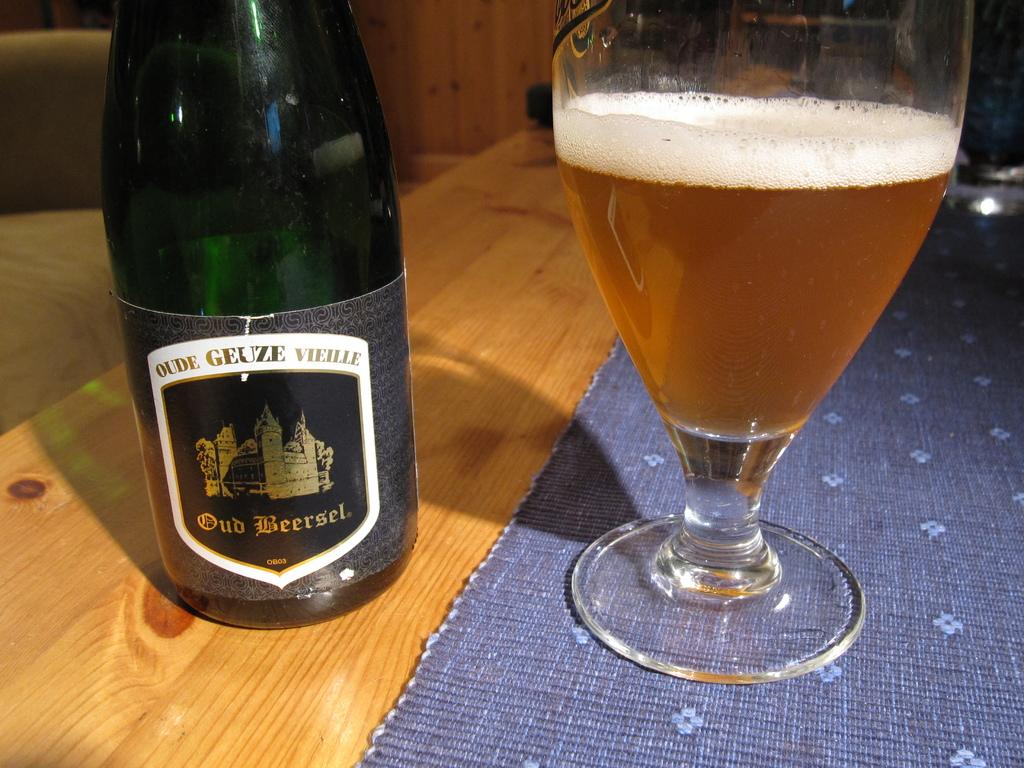Provide a one-sentence caption for the provided image. A bottle of Old Beersel sits next to a clear glass with the poured drink inside. 